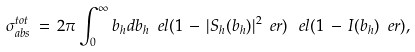<formula> <loc_0><loc_0><loc_500><loc_500>\sigma _ { a b s } ^ { t o t } \, = \, 2 \pi \int _ { 0 } ^ { \infty } b _ { h } d b _ { h } \ e l ( 1 \, - \, | S _ { h } ( b _ { h } ) | ^ { 2 } \ e r ) \, \ e l ( 1 \, - \, I ( b _ { h } ) \ e r ) ,</formula> 